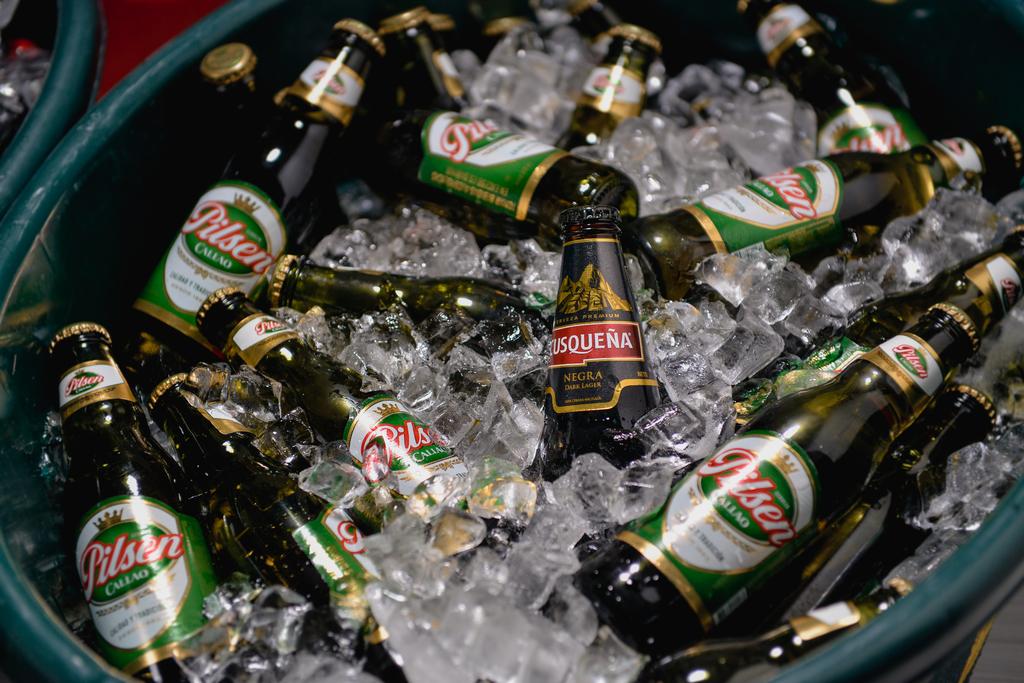Where is the middle beer from?
Offer a very short reply. Negra. 